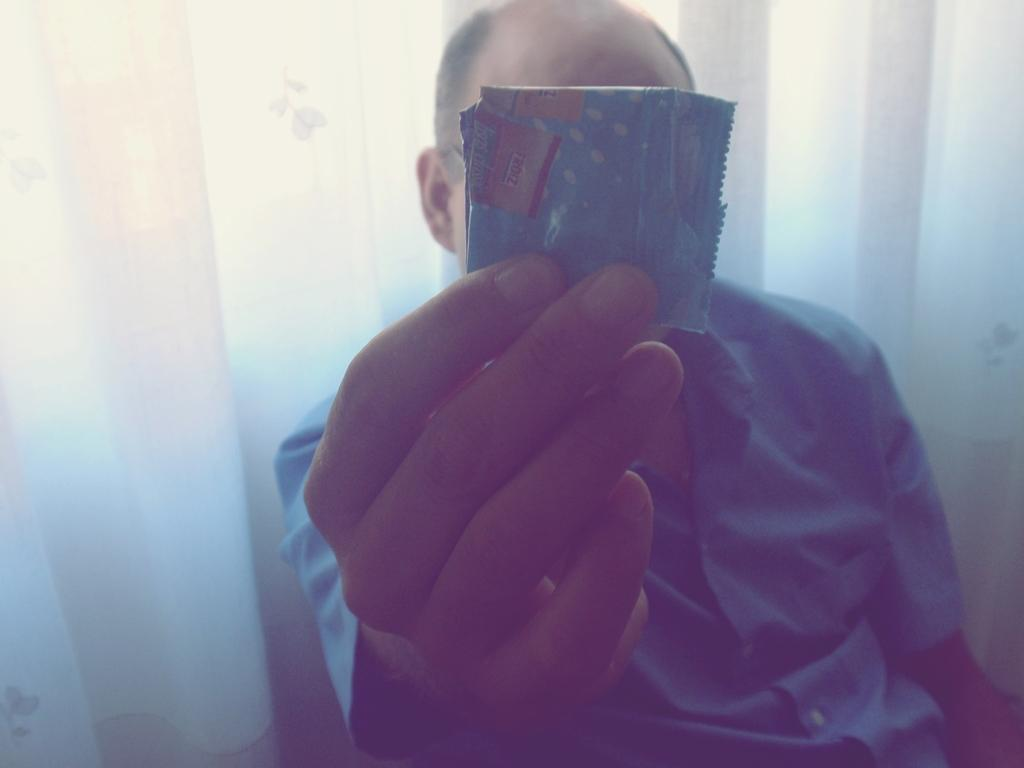What is happening in the image? There is a person in the image who is catching an object with their hand. What can be seen behind the person? There is a curtain visible behind the person. What type of authority does the person in the image have over the egg? There is no egg present in the image, so the question of authority over an egg is not applicable. 